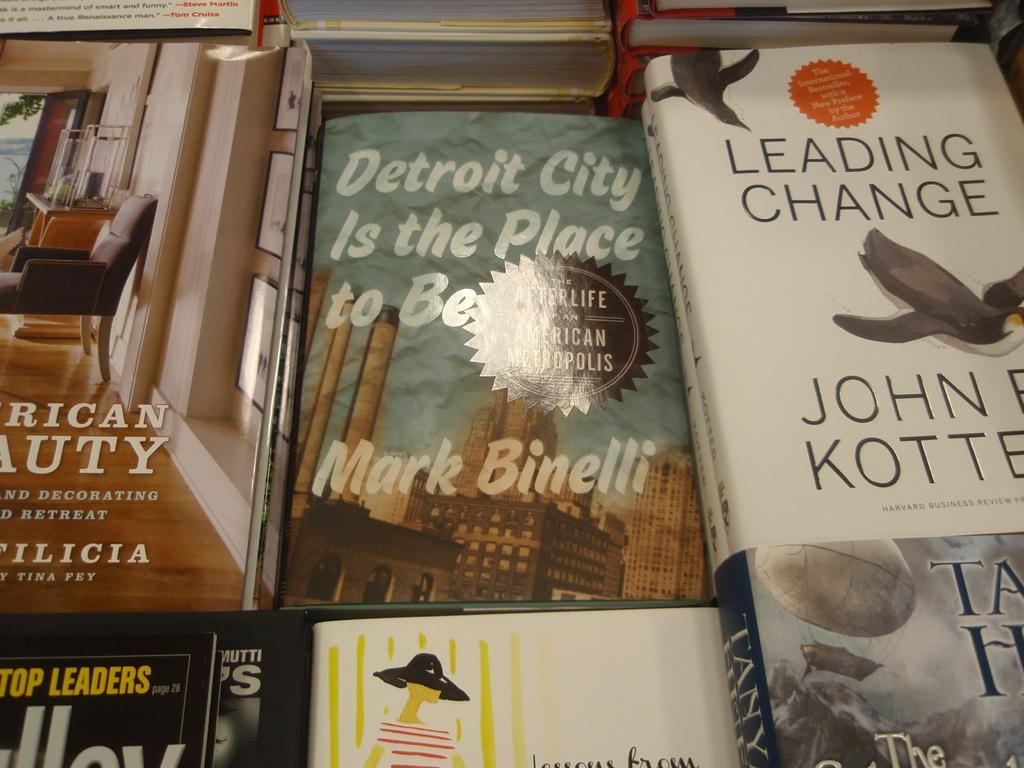<image>
Provide a brief description of the given image. a bunch of books by each other with one named 'leading change' 